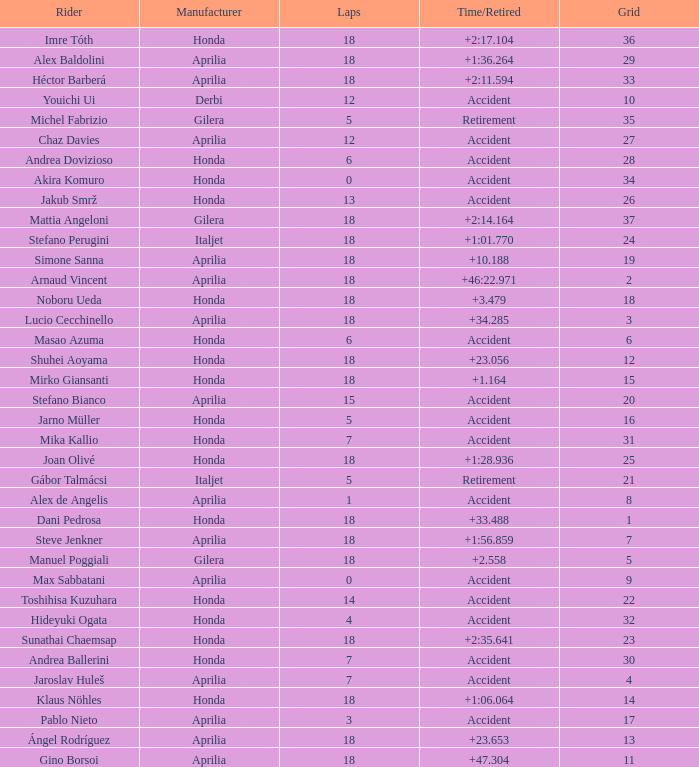Who is the rider with less than 15 laps, more than 32 grids, and an accident time/retired? Akira Komuro. 